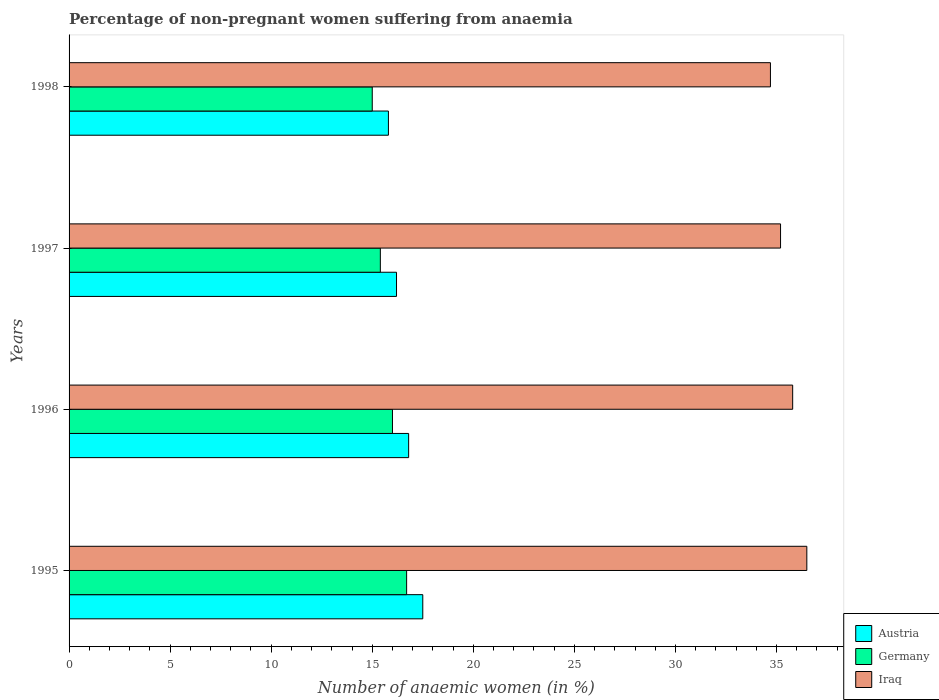Are the number of bars on each tick of the Y-axis equal?
Ensure brevity in your answer.  Yes. What is the percentage of non-pregnant women suffering from anaemia in Germany in 1998?
Make the answer very short. 15. Across all years, what is the maximum percentage of non-pregnant women suffering from anaemia in Germany?
Your answer should be very brief. 16.7. Across all years, what is the minimum percentage of non-pregnant women suffering from anaemia in Germany?
Your answer should be very brief. 15. In which year was the percentage of non-pregnant women suffering from anaemia in Iraq maximum?
Your answer should be compact. 1995. What is the total percentage of non-pregnant women suffering from anaemia in Germany in the graph?
Your answer should be very brief. 63.1. What is the difference between the percentage of non-pregnant women suffering from anaemia in Germany in 1996 and that in 1997?
Ensure brevity in your answer.  0.6. What is the difference between the percentage of non-pregnant women suffering from anaemia in Austria in 1996 and the percentage of non-pregnant women suffering from anaemia in Iraq in 1998?
Keep it short and to the point. -17.9. What is the average percentage of non-pregnant women suffering from anaemia in Austria per year?
Provide a succinct answer. 16.57. What is the ratio of the percentage of non-pregnant women suffering from anaemia in Germany in 1996 to that in 1997?
Offer a very short reply. 1.04. Is the percentage of non-pregnant women suffering from anaemia in Iraq in 1996 less than that in 1998?
Your answer should be compact. No. What is the difference between the highest and the second highest percentage of non-pregnant women suffering from anaemia in Germany?
Offer a terse response. 0.7. What is the difference between the highest and the lowest percentage of non-pregnant women suffering from anaemia in Austria?
Offer a terse response. 1.7. What does the 2nd bar from the top in 1996 represents?
Offer a terse response. Germany. What does the 2nd bar from the bottom in 1995 represents?
Your answer should be compact. Germany. Is it the case that in every year, the sum of the percentage of non-pregnant women suffering from anaemia in Germany and percentage of non-pregnant women suffering from anaemia in Iraq is greater than the percentage of non-pregnant women suffering from anaemia in Austria?
Ensure brevity in your answer.  Yes. Are all the bars in the graph horizontal?
Your response must be concise. Yes. What is the difference between two consecutive major ticks on the X-axis?
Make the answer very short. 5. Does the graph contain grids?
Your response must be concise. No. Where does the legend appear in the graph?
Keep it short and to the point. Bottom right. How many legend labels are there?
Offer a terse response. 3. What is the title of the graph?
Your answer should be very brief. Percentage of non-pregnant women suffering from anaemia. Does "Eritrea" appear as one of the legend labels in the graph?
Your answer should be compact. No. What is the label or title of the X-axis?
Your response must be concise. Number of anaemic women (in %). What is the Number of anaemic women (in %) of Iraq in 1995?
Offer a very short reply. 36.5. What is the Number of anaemic women (in %) in Austria in 1996?
Provide a succinct answer. 16.8. What is the Number of anaemic women (in %) of Germany in 1996?
Provide a succinct answer. 16. What is the Number of anaemic women (in %) of Iraq in 1996?
Provide a succinct answer. 35.8. What is the Number of anaemic women (in %) in Austria in 1997?
Your response must be concise. 16.2. What is the Number of anaemic women (in %) in Iraq in 1997?
Provide a succinct answer. 35.2. What is the Number of anaemic women (in %) of Austria in 1998?
Your answer should be compact. 15.8. What is the Number of anaemic women (in %) in Iraq in 1998?
Ensure brevity in your answer.  34.7. Across all years, what is the maximum Number of anaemic women (in %) in Austria?
Give a very brief answer. 17.5. Across all years, what is the maximum Number of anaemic women (in %) of Germany?
Make the answer very short. 16.7. Across all years, what is the maximum Number of anaemic women (in %) in Iraq?
Provide a short and direct response. 36.5. Across all years, what is the minimum Number of anaemic women (in %) in Iraq?
Your answer should be compact. 34.7. What is the total Number of anaemic women (in %) of Austria in the graph?
Your response must be concise. 66.3. What is the total Number of anaemic women (in %) in Germany in the graph?
Keep it short and to the point. 63.1. What is the total Number of anaemic women (in %) in Iraq in the graph?
Offer a very short reply. 142.2. What is the difference between the Number of anaemic women (in %) of Germany in 1995 and that in 1996?
Make the answer very short. 0.7. What is the difference between the Number of anaemic women (in %) in Iraq in 1995 and that in 1996?
Offer a very short reply. 0.7. What is the difference between the Number of anaemic women (in %) in Germany in 1996 and that in 1997?
Your answer should be compact. 0.6. What is the difference between the Number of anaemic women (in %) of Germany in 1996 and that in 1998?
Provide a short and direct response. 1. What is the difference between the Number of anaemic women (in %) in Germany in 1997 and that in 1998?
Provide a succinct answer. 0.4. What is the difference between the Number of anaemic women (in %) of Iraq in 1997 and that in 1998?
Ensure brevity in your answer.  0.5. What is the difference between the Number of anaemic women (in %) of Austria in 1995 and the Number of anaemic women (in %) of Germany in 1996?
Keep it short and to the point. 1.5. What is the difference between the Number of anaemic women (in %) of Austria in 1995 and the Number of anaemic women (in %) of Iraq in 1996?
Make the answer very short. -18.3. What is the difference between the Number of anaemic women (in %) of Germany in 1995 and the Number of anaemic women (in %) of Iraq in 1996?
Offer a very short reply. -19.1. What is the difference between the Number of anaemic women (in %) in Austria in 1995 and the Number of anaemic women (in %) in Iraq in 1997?
Make the answer very short. -17.7. What is the difference between the Number of anaemic women (in %) of Germany in 1995 and the Number of anaemic women (in %) of Iraq in 1997?
Your response must be concise. -18.5. What is the difference between the Number of anaemic women (in %) of Austria in 1995 and the Number of anaemic women (in %) of Germany in 1998?
Ensure brevity in your answer.  2.5. What is the difference between the Number of anaemic women (in %) in Austria in 1995 and the Number of anaemic women (in %) in Iraq in 1998?
Provide a short and direct response. -17.2. What is the difference between the Number of anaemic women (in %) of Germany in 1995 and the Number of anaemic women (in %) of Iraq in 1998?
Provide a succinct answer. -18. What is the difference between the Number of anaemic women (in %) of Austria in 1996 and the Number of anaemic women (in %) of Iraq in 1997?
Your response must be concise. -18.4. What is the difference between the Number of anaemic women (in %) in Germany in 1996 and the Number of anaemic women (in %) in Iraq in 1997?
Keep it short and to the point. -19.2. What is the difference between the Number of anaemic women (in %) in Austria in 1996 and the Number of anaemic women (in %) in Iraq in 1998?
Keep it short and to the point. -17.9. What is the difference between the Number of anaemic women (in %) of Germany in 1996 and the Number of anaemic women (in %) of Iraq in 1998?
Provide a succinct answer. -18.7. What is the difference between the Number of anaemic women (in %) in Austria in 1997 and the Number of anaemic women (in %) in Germany in 1998?
Give a very brief answer. 1.2. What is the difference between the Number of anaemic women (in %) of Austria in 1997 and the Number of anaemic women (in %) of Iraq in 1998?
Offer a terse response. -18.5. What is the difference between the Number of anaemic women (in %) of Germany in 1997 and the Number of anaemic women (in %) of Iraq in 1998?
Make the answer very short. -19.3. What is the average Number of anaemic women (in %) in Austria per year?
Your answer should be very brief. 16.57. What is the average Number of anaemic women (in %) in Germany per year?
Your response must be concise. 15.78. What is the average Number of anaemic women (in %) in Iraq per year?
Your response must be concise. 35.55. In the year 1995, what is the difference between the Number of anaemic women (in %) of Austria and Number of anaemic women (in %) of Germany?
Keep it short and to the point. 0.8. In the year 1995, what is the difference between the Number of anaemic women (in %) in Austria and Number of anaemic women (in %) in Iraq?
Make the answer very short. -19. In the year 1995, what is the difference between the Number of anaemic women (in %) in Germany and Number of anaemic women (in %) in Iraq?
Make the answer very short. -19.8. In the year 1996, what is the difference between the Number of anaemic women (in %) in Austria and Number of anaemic women (in %) in Iraq?
Provide a short and direct response. -19. In the year 1996, what is the difference between the Number of anaemic women (in %) of Germany and Number of anaemic women (in %) of Iraq?
Ensure brevity in your answer.  -19.8. In the year 1997, what is the difference between the Number of anaemic women (in %) in Germany and Number of anaemic women (in %) in Iraq?
Ensure brevity in your answer.  -19.8. In the year 1998, what is the difference between the Number of anaemic women (in %) of Austria and Number of anaemic women (in %) of Iraq?
Provide a succinct answer. -18.9. In the year 1998, what is the difference between the Number of anaemic women (in %) in Germany and Number of anaemic women (in %) in Iraq?
Give a very brief answer. -19.7. What is the ratio of the Number of anaemic women (in %) in Austria in 1995 to that in 1996?
Provide a short and direct response. 1.04. What is the ratio of the Number of anaemic women (in %) of Germany in 1995 to that in 1996?
Your answer should be compact. 1.04. What is the ratio of the Number of anaemic women (in %) of Iraq in 1995 to that in 1996?
Your answer should be compact. 1.02. What is the ratio of the Number of anaemic women (in %) of Austria in 1995 to that in 1997?
Your answer should be very brief. 1.08. What is the ratio of the Number of anaemic women (in %) in Germany in 1995 to that in 1997?
Ensure brevity in your answer.  1.08. What is the ratio of the Number of anaemic women (in %) in Iraq in 1995 to that in 1997?
Ensure brevity in your answer.  1.04. What is the ratio of the Number of anaemic women (in %) in Austria in 1995 to that in 1998?
Ensure brevity in your answer.  1.11. What is the ratio of the Number of anaemic women (in %) in Germany in 1995 to that in 1998?
Provide a succinct answer. 1.11. What is the ratio of the Number of anaemic women (in %) in Iraq in 1995 to that in 1998?
Offer a terse response. 1.05. What is the ratio of the Number of anaemic women (in %) in Germany in 1996 to that in 1997?
Your response must be concise. 1.04. What is the ratio of the Number of anaemic women (in %) of Austria in 1996 to that in 1998?
Your answer should be compact. 1.06. What is the ratio of the Number of anaemic women (in %) of Germany in 1996 to that in 1998?
Your answer should be compact. 1.07. What is the ratio of the Number of anaemic women (in %) in Iraq in 1996 to that in 1998?
Your answer should be very brief. 1.03. What is the ratio of the Number of anaemic women (in %) of Austria in 1997 to that in 1998?
Provide a succinct answer. 1.03. What is the ratio of the Number of anaemic women (in %) in Germany in 1997 to that in 1998?
Make the answer very short. 1.03. What is the ratio of the Number of anaemic women (in %) in Iraq in 1997 to that in 1998?
Give a very brief answer. 1.01. What is the difference between the highest and the second highest Number of anaemic women (in %) in Austria?
Provide a succinct answer. 0.7. What is the difference between the highest and the lowest Number of anaemic women (in %) of Iraq?
Your answer should be compact. 1.8. 